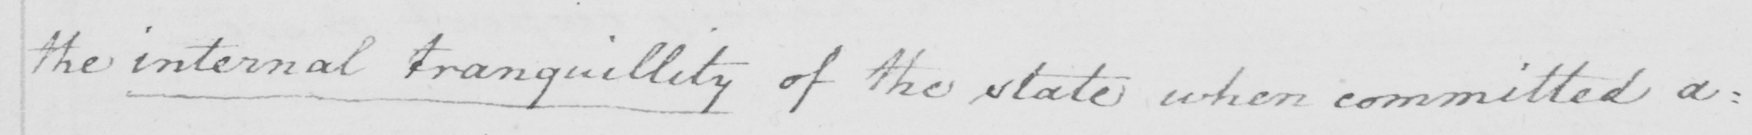Please provide the text content of this handwritten line. the internal tranquillity of the state when committed a= 